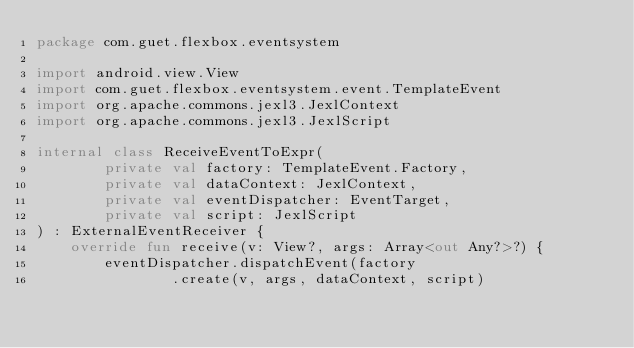<code> <loc_0><loc_0><loc_500><loc_500><_Kotlin_>package com.guet.flexbox.eventsystem

import android.view.View
import com.guet.flexbox.eventsystem.event.TemplateEvent
import org.apache.commons.jexl3.JexlContext
import org.apache.commons.jexl3.JexlScript

internal class ReceiveEventToExpr(
        private val factory: TemplateEvent.Factory,
        private val dataContext: JexlContext,
        private val eventDispatcher: EventTarget,
        private val script: JexlScript
) : ExternalEventReceiver {
    override fun receive(v: View?, args: Array<out Any?>?) {
        eventDispatcher.dispatchEvent(factory
                .create(v, args, dataContext, script)</code> 